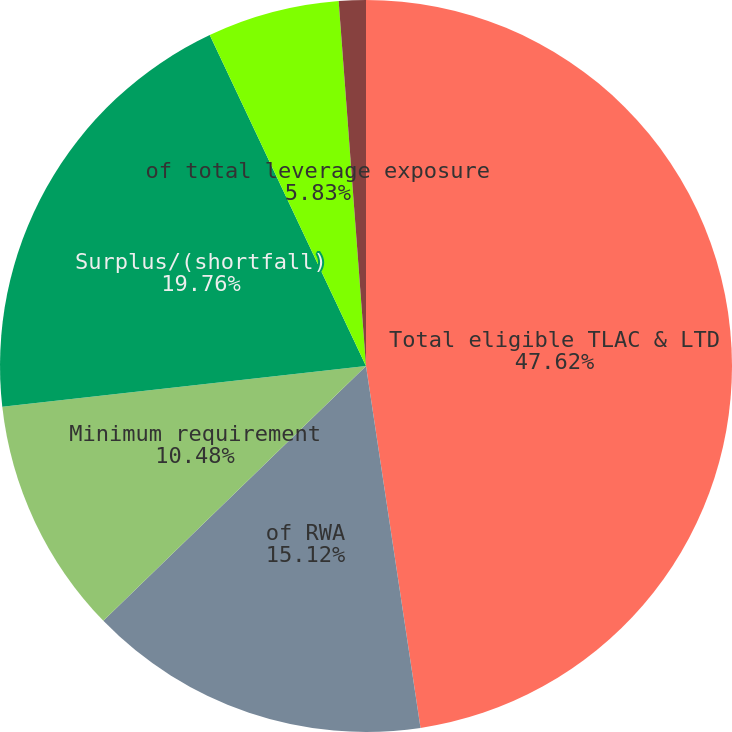<chart> <loc_0><loc_0><loc_500><loc_500><pie_chart><fcel>Total eligible TLAC & LTD<fcel>of RWA<fcel>Minimum requirement<fcel>Surplus/(shortfall)<fcel>of total leverage exposure<fcel>Minimum requirement (a)<nl><fcel>47.62%<fcel>15.12%<fcel>10.48%<fcel>19.76%<fcel>5.83%<fcel>1.19%<nl></chart> 